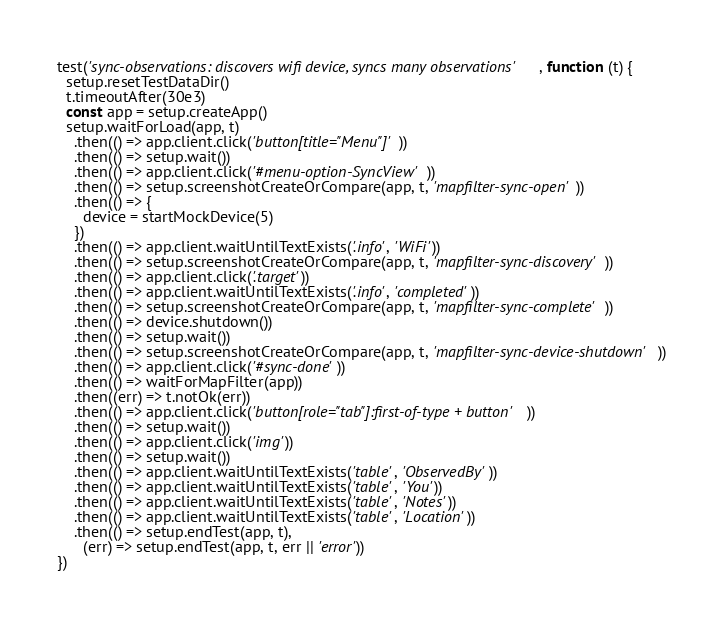<code> <loc_0><loc_0><loc_500><loc_500><_JavaScript_>
test('sync-observations: discovers wifi device, syncs many observations', function (t) {
  setup.resetTestDataDir()
  t.timeoutAfter(30e3)
  const app = setup.createApp()
  setup.waitForLoad(app, t)
    .then(() => app.client.click('button[title="Menu"]'))
    .then(() => setup.wait())
    .then(() => app.client.click('#menu-option-SyncView'))
    .then(() => setup.screenshotCreateOrCompare(app, t, 'mapfilter-sync-open'))
    .then(() => {
      device = startMockDevice(5)
    })
    .then(() => app.client.waitUntilTextExists('.info', 'WiFi'))
    .then(() => setup.screenshotCreateOrCompare(app, t, 'mapfilter-sync-discovery'))
    .then(() => app.client.click('.target'))
    .then(() => app.client.waitUntilTextExists('.info', 'completed'))
    .then(() => setup.screenshotCreateOrCompare(app, t, 'mapfilter-sync-complete'))
    .then(() => device.shutdown())
    .then(() => setup.wait())
    .then(() => setup.screenshotCreateOrCompare(app, t, 'mapfilter-sync-device-shutdown'))
    .then(() => app.client.click('#sync-done'))
    .then(() => waitForMapFilter(app))
    .then((err) => t.notOk(err))
    .then(() => app.client.click('button[role="tab"]:first-of-type + button'))
    .then(() => setup.wait())
    .then(() => app.client.click('img'))
    .then(() => setup.wait())
    .then(() => app.client.waitUntilTextExists('table', 'ObservedBy'))
    .then(() => app.client.waitUntilTextExists('table', 'You'))
    .then(() => app.client.waitUntilTextExists('table', 'Notes'))
    .then(() => app.client.waitUntilTextExists('table', 'Location'))
    .then(() => setup.endTest(app, t),
      (err) => setup.endTest(app, t, err || 'error'))
})
</code> 